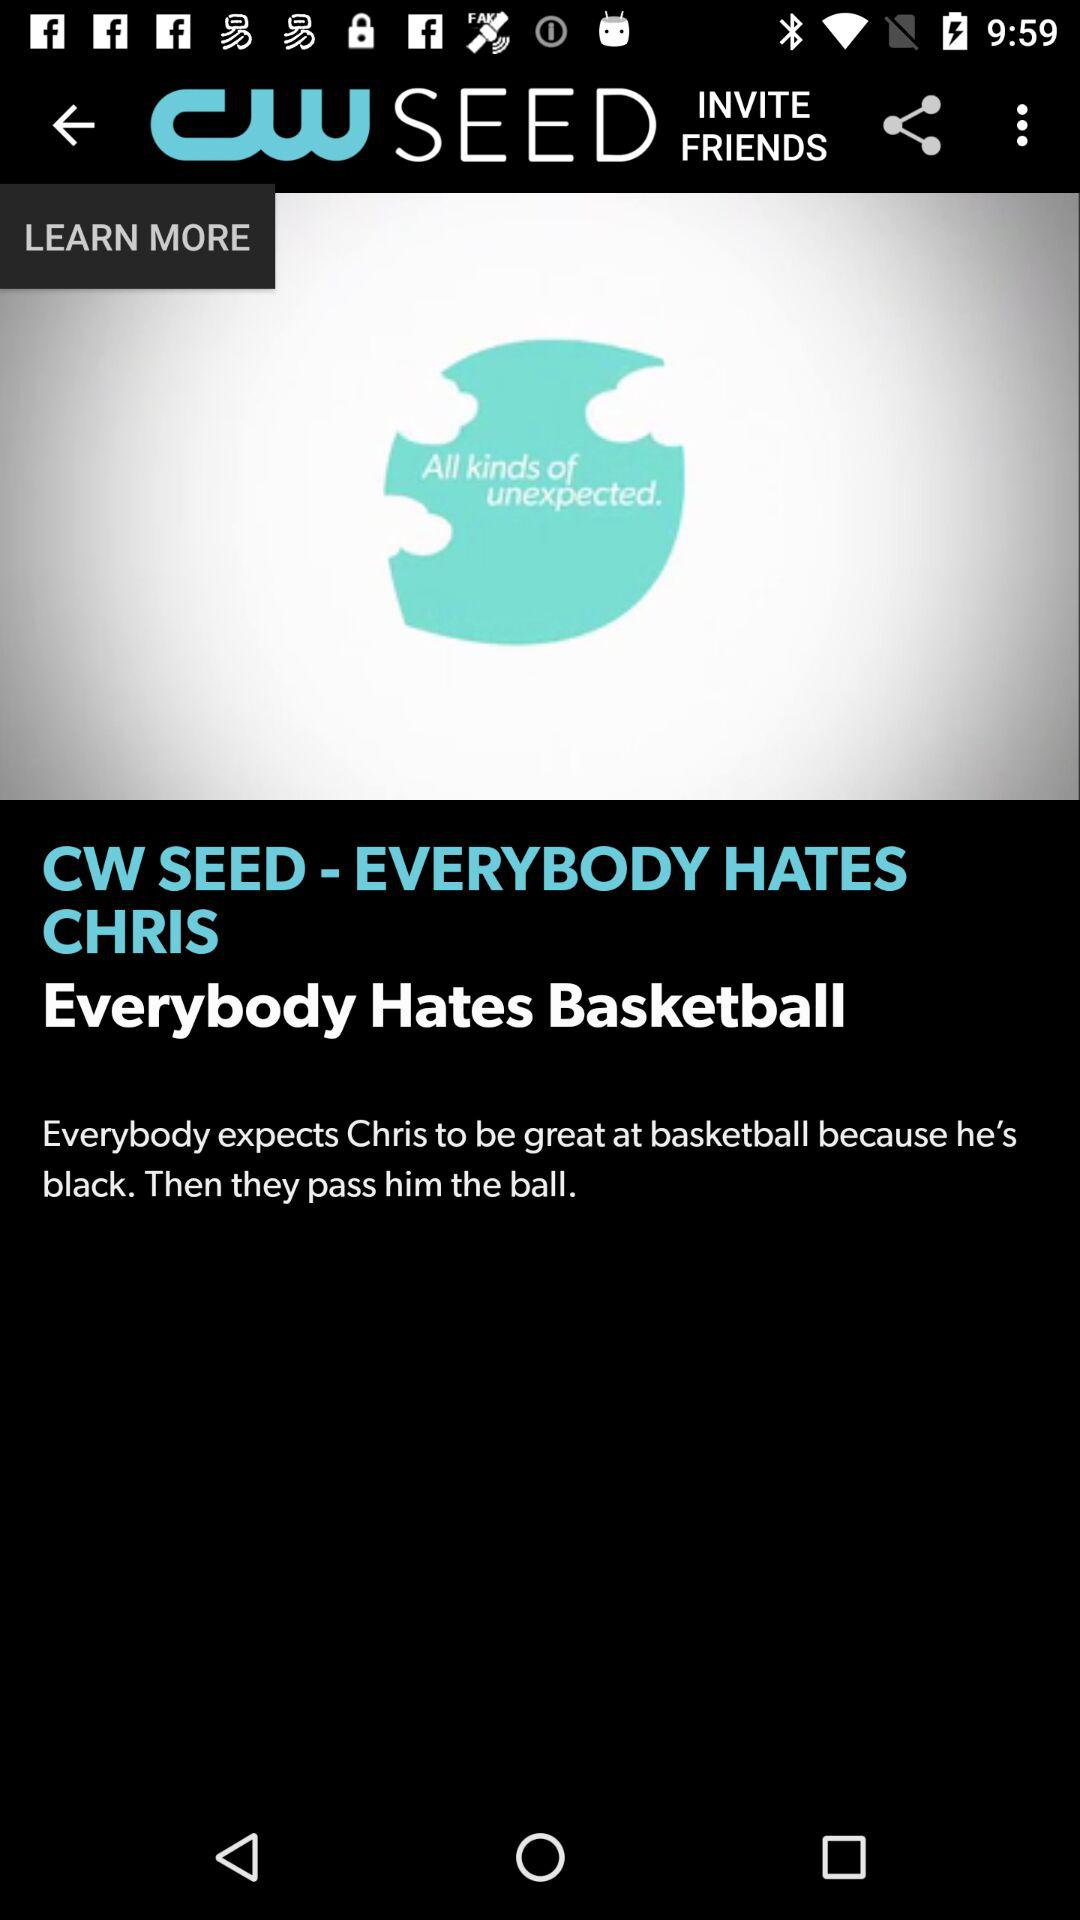What is the application name? The application name is "CW SEED". 